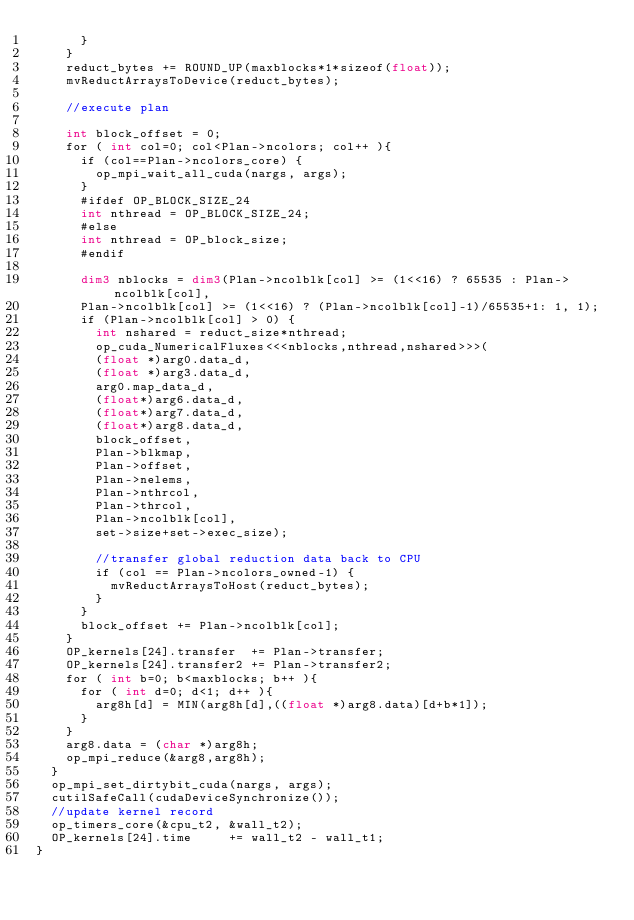Convert code to text. <code><loc_0><loc_0><loc_500><loc_500><_Cuda_>      }
    }
    reduct_bytes += ROUND_UP(maxblocks*1*sizeof(float));
    mvReductArraysToDevice(reduct_bytes);

    //execute plan

    int block_offset = 0;
    for ( int col=0; col<Plan->ncolors; col++ ){
      if (col==Plan->ncolors_core) {
        op_mpi_wait_all_cuda(nargs, args);
      }
      #ifdef OP_BLOCK_SIZE_24
      int nthread = OP_BLOCK_SIZE_24;
      #else
      int nthread = OP_block_size;
      #endif

      dim3 nblocks = dim3(Plan->ncolblk[col] >= (1<<16) ? 65535 : Plan->ncolblk[col],
      Plan->ncolblk[col] >= (1<<16) ? (Plan->ncolblk[col]-1)/65535+1: 1, 1);
      if (Plan->ncolblk[col] > 0) {
        int nshared = reduct_size*nthread;
        op_cuda_NumericalFluxes<<<nblocks,nthread,nshared>>>(
        (float *)arg0.data_d,
        (float *)arg3.data_d,
        arg0.map_data_d,
        (float*)arg6.data_d,
        (float*)arg7.data_d,
        (float*)arg8.data_d,
        block_offset,
        Plan->blkmap,
        Plan->offset,
        Plan->nelems,
        Plan->nthrcol,
        Plan->thrcol,
        Plan->ncolblk[col],
        set->size+set->exec_size);

        //transfer global reduction data back to CPU
        if (col == Plan->ncolors_owned-1) {
          mvReductArraysToHost(reduct_bytes);
        }
      }
      block_offset += Plan->ncolblk[col];
    }
    OP_kernels[24].transfer  += Plan->transfer;
    OP_kernels[24].transfer2 += Plan->transfer2;
    for ( int b=0; b<maxblocks; b++ ){
      for ( int d=0; d<1; d++ ){
        arg8h[d] = MIN(arg8h[d],((float *)arg8.data)[d+b*1]);
      }
    }
    arg8.data = (char *)arg8h;
    op_mpi_reduce(&arg8,arg8h);
  }
  op_mpi_set_dirtybit_cuda(nargs, args);
  cutilSafeCall(cudaDeviceSynchronize());
  //update kernel record
  op_timers_core(&cpu_t2, &wall_t2);
  OP_kernels[24].time     += wall_t2 - wall_t1;
}
</code> 